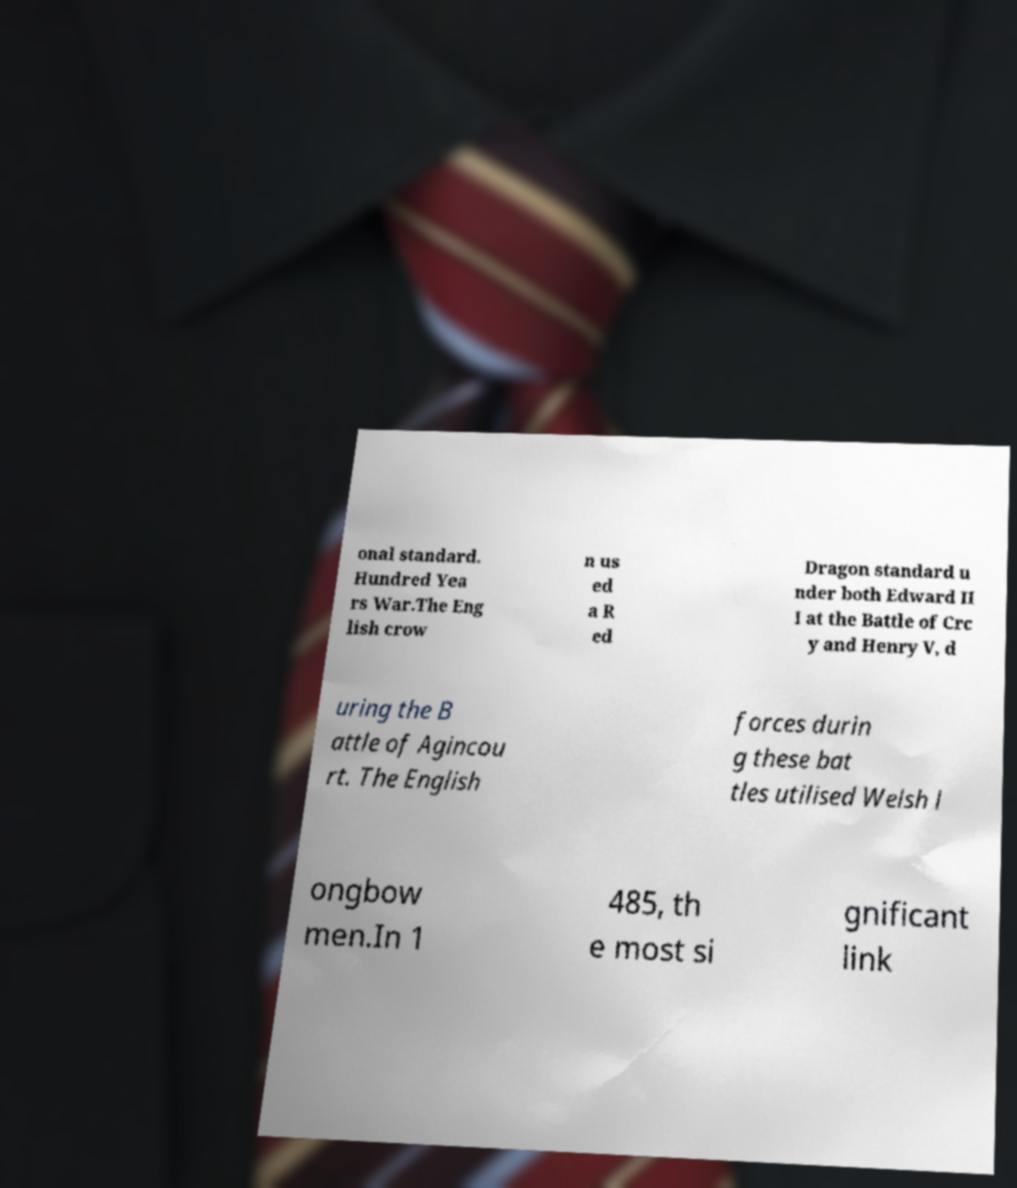What messages or text are displayed in this image? I need them in a readable, typed format. onal standard. Hundred Yea rs War.The Eng lish crow n us ed a R ed Dragon standard u nder both Edward II I at the Battle of Crc y and Henry V, d uring the B attle of Agincou rt. The English forces durin g these bat tles utilised Welsh l ongbow men.In 1 485, th e most si gnificant link 